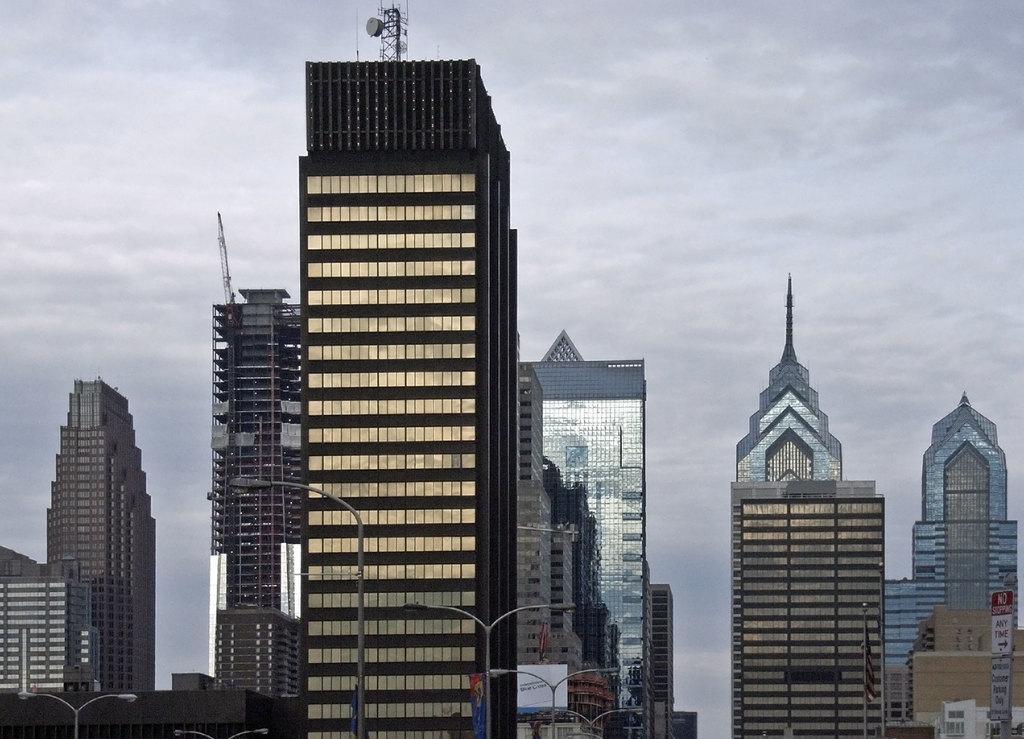How would you summarize this image in a sentence or two? In this image we can see so many big buildings, some street lights, some boards with text, some antennas are at the top of the buildings and at the top there is the cloudy sky. 